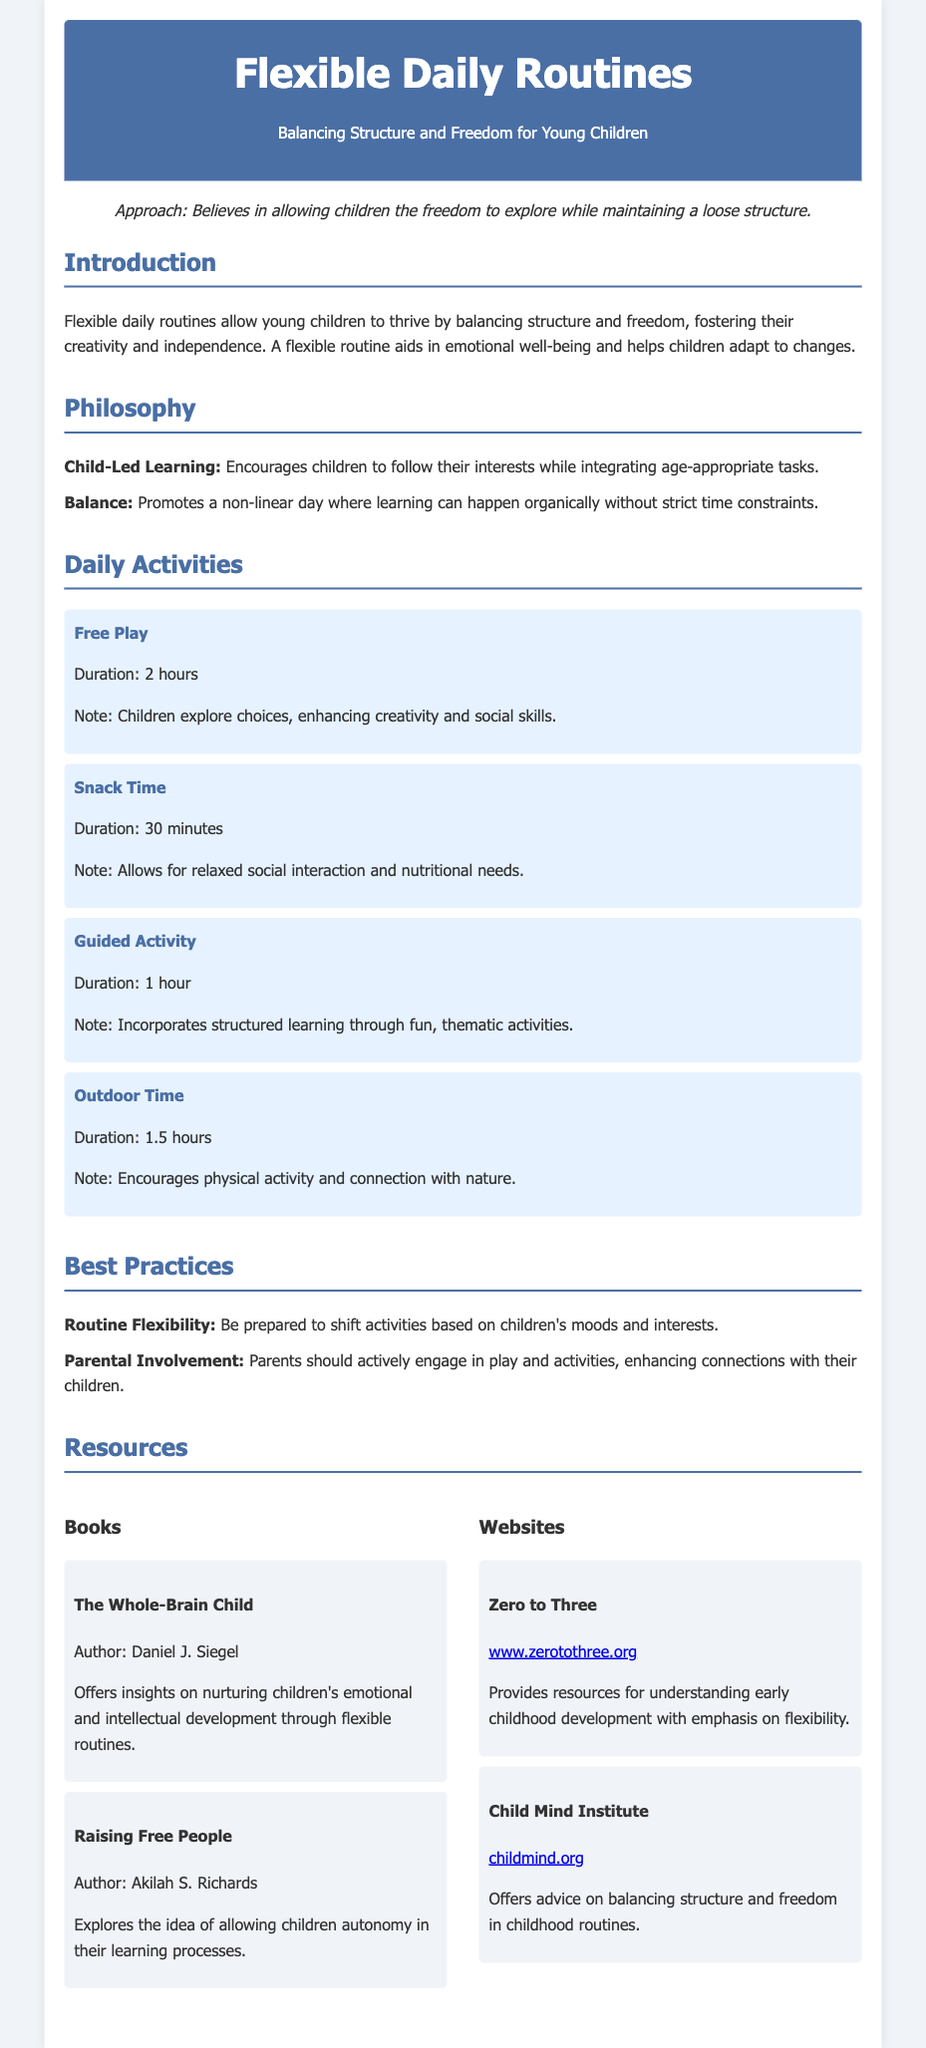what is the title of the document? The title is prominently displayed at the top of the document.
Answer: Flexible Daily Routines who is the author of "The Whole-Brain Child"? The author is mentioned in the resources section of the document.
Answer: Daniel J. Siegel how long is the duration of Free Play? The duration is specified in the daily activities section of the document.
Answer: 2 hours what is the main philosophy mentioned in the document? The philosophies are outlined in a specific section of the document.
Answer: Child-Led Learning how many total hours are allocated for outdoor time? The duration is listed in the daily activities section and can be added up.
Answer: 1.5 hours what is one of the best practices suggested for routine flexibility? This information is found in the best practices section of the document.
Answer: Shift activities based on children's moods which organization provides resources for early childhood development? This is mentioned in the websites section of the document.
Answer: Zero to Three how long is the duration of snack time? The duration is provided in the daily activities section of the document.
Answer: 30 minutes what is the focus of "Raising Free People"? The focus is derived from the summary provided in the resources section.
Answer: Autonomy in learning 